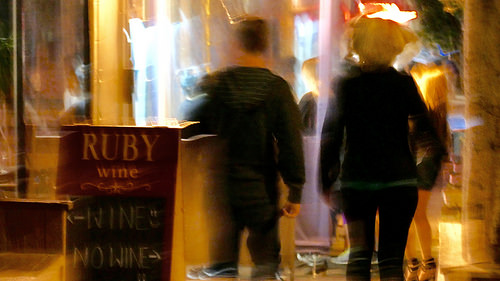<image>
Can you confirm if the counter is to the left of the man? Yes. From this viewpoint, the counter is positioned to the left side relative to the man. 